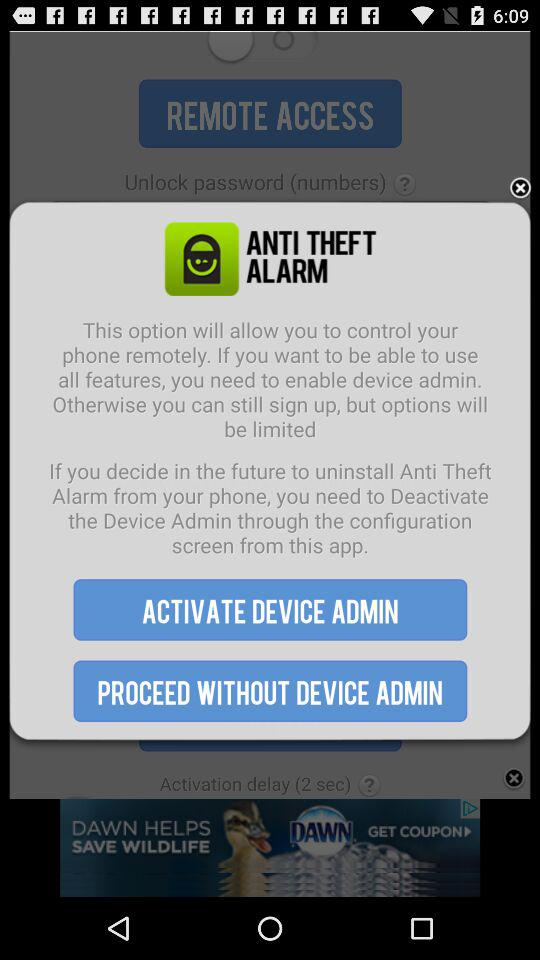What is the app name? The app name is "ANTI THEFT ALARM". 